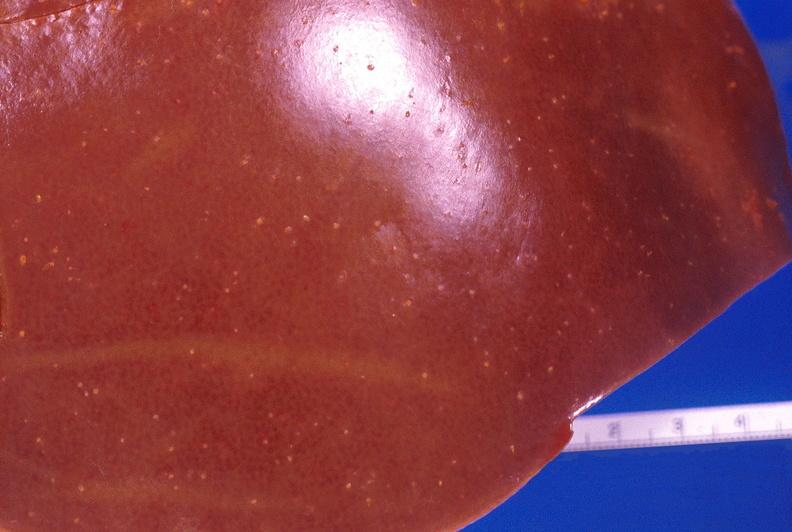does this image show liver, candida abscesses?
Answer the question using a single word or phrase. Yes 